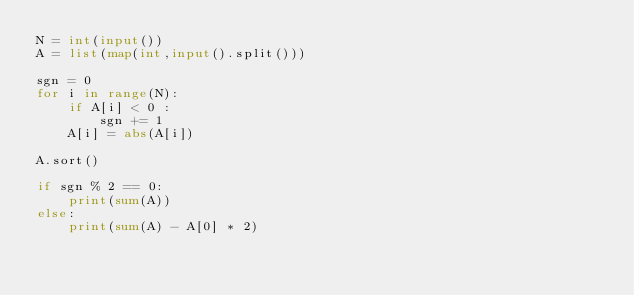Convert code to text. <code><loc_0><loc_0><loc_500><loc_500><_Python_>N = int(input())
A = list(map(int,input().split()))

sgn = 0
for i in range(N):
    if A[i] < 0 :
        sgn += 1
    A[i] = abs(A[i])

A.sort()

if sgn % 2 == 0:
    print(sum(A))
else:
    print(sum(A) - A[0] * 2)</code> 